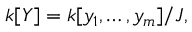Convert formula to latex. <formula><loc_0><loc_0><loc_500><loc_500>k [ Y ] = k [ y _ { 1 } , \dots , y _ { m } ] / J ,</formula> 